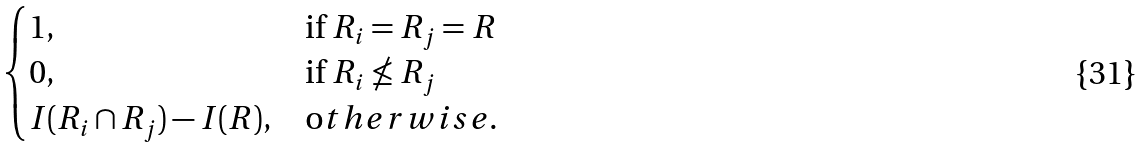<formula> <loc_0><loc_0><loc_500><loc_500>\begin{cases} 1 , & \text {if $R_{i}=R_{j}=R$} \\ 0 , & \text {if $R_{i}\nleq R_{j}$} \\ I ( R _ { i } \cap R _ { j } ) - I ( R ) , & { \text  otherwise.} \end{cases}</formula> 